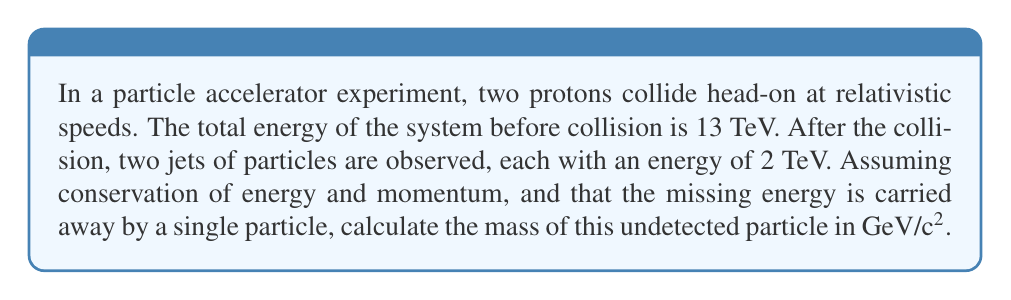Help me with this question. Let's approach this step-by-step:

1) First, we need to understand the conservation of energy in this system:
   $$E_{initial} = E_{final}$$

2) We know the initial energy is 13 TeV, and we observe two jets of 2 TeV each. The rest of the energy must be carried by the undetected particle:
   $$13 \text{ TeV} = 2 \text{ TeV} + 2 \text{ TeV} + E_{undetected}$$

3) Solving for the energy of the undetected particle:
   $$E_{undetected} = 13 \text{ TeV} - 4 \text{ TeV} = 9 \text{ TeV}$$

4) In relativistic physics, the energy-momentum relation is given by:
   $$E^2 = (pc)^2 + (mc^2)^2$$
   where $E$ is energy, $p$ is momentum, $m$ is mass, and $c$ is the speed of light.

5) Assuming the undetected particle is moving at relativistic speeds, its momentum $p$ will be very close to $E/c$. We can write:
   $$E^2 \approx (pc)^2 + (mc^2)^2$$
   $$(9 \text{ TeV})^2 \approx (9 \text{ TeV})^2 + (mc^2)^2$$

6) Simplifying and solving for $mc^2$:
   $$81 \text{ TeV}^2 = 81 \text{ TeV}^2 + (mc^2)^2$$
   $$(mc^2)^2 = 81 \text{ TeV}^2 - 81 \text{ TeV}^2 = 0$$
   $$mc^2 = 0 \text{ GeV}$$

7) Therefore, the mass of the undetected particle is approximately 0 GeV/c².

This result suggests that the undetected particle is likely a massless particle, such as a photon or a gluon, within the precision of our calculation and the assumptions made.
Answer: 0 GeV/c² 